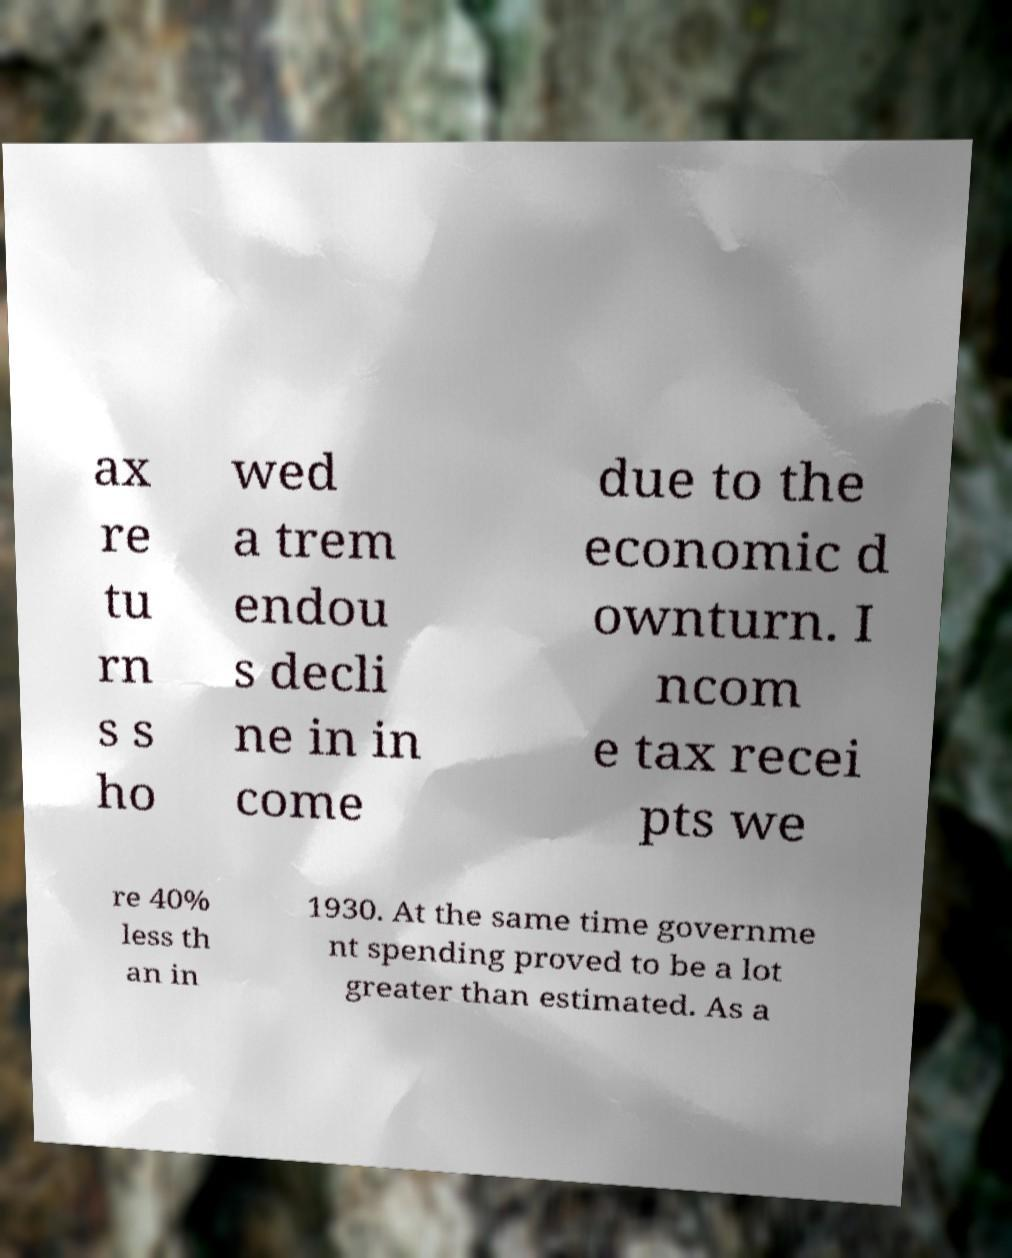There's text embedded in this image that I need extracted. Can you transcribe it verbatim? ax re tu rn s s ho wed a trem endou s decli ne in in come due to the economic d ownturn. I ncom e tax recei pts we re 40% less th an in 1930. At the same time governme nt spending proved to be a lot greater than estimated. As a 